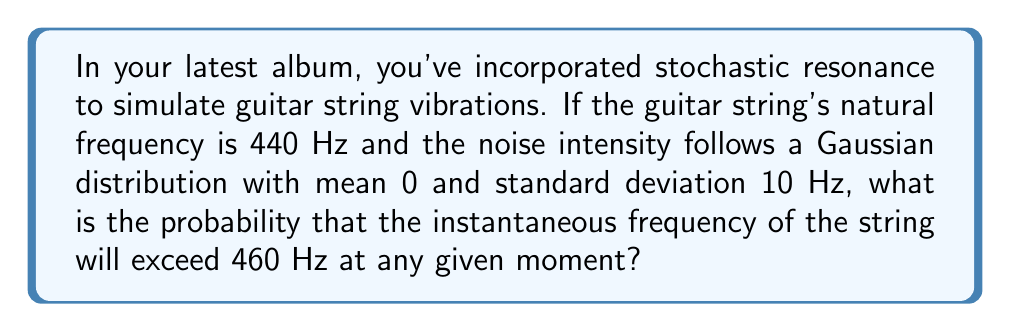What is the answer to this math problem? Let's approach this step-by-step:

1) The natural frequency of the string is 440 Hz. This is our baseline.

2) The noise intensity follows a Gaussian (Normal) distribution with:
   mean (μ) = 0 Hz
   standard deviation (σ) = 10 Hz

3) We want to find the probability that the instantaneous frequency exceeds 460 Hz. This means we need to calculate:

   P(X > 460 - 440), where X is the noise distribution

   This simplifies to P(X > 20)

4) To solve this, we need to calculate the z-score:

   $$z = \frac{x - μ}{σ} = \frac{20 - 0}{10} = 2$$

5) Now, we need to find P(Z > 2) where Z is the standard normal distribution.

6) Using a standard normal table or calculator, we can find that:

   P(Z > 2) ≈ 0.0228

7) Therefore, the probability that the instantaneous frequency exceeds 460 Hz is approximately 0.0228 or 2.28%.
Answer: 0.0228 